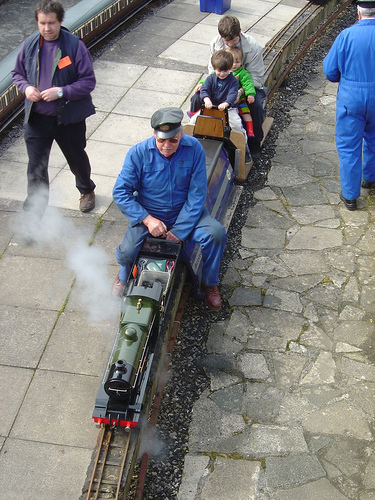<image>
Is the sidewalk next to the bin? Yes. The sidewalk is positioned adjacent to the bin, located nearby in the same general area. Is the man on the train? Yes. Looking at the image, I can see the man is positioned on top of the train, with the train providing support. 